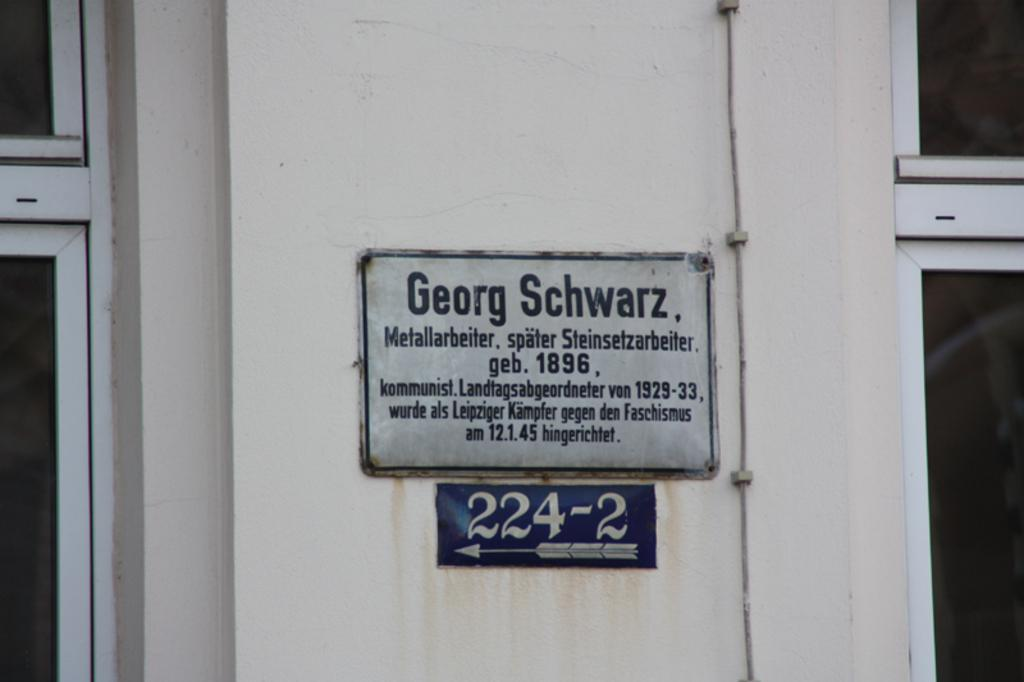What is the main feature in the image? There is a hoarding in the image. What color is the signboard on the wall of the building? The signboard on the wall of the building is violet. What type of windows does the building have? The building has glass windows. Can you see a comb in the image? There is no comb present in the image. What type of leaf is on the signboard in the image? There are no leaves on the signboard in the image; it is a violet color signboard. 